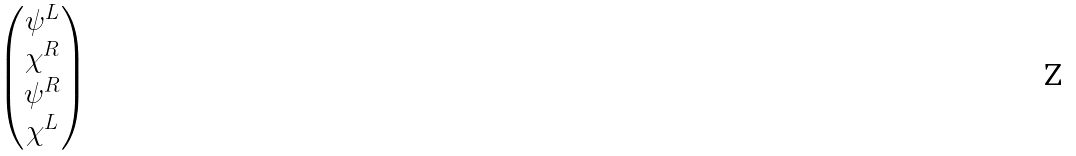Convert formula to latex. <formula><loc_0><loc_0><loc_500><loc_500>\begin{pmatrix} \psi ^ { L } \\ \chi ^ { R } \\ \psi ^ { R } \\ \chi ^ { L } \end{pmatrix}</formula> 